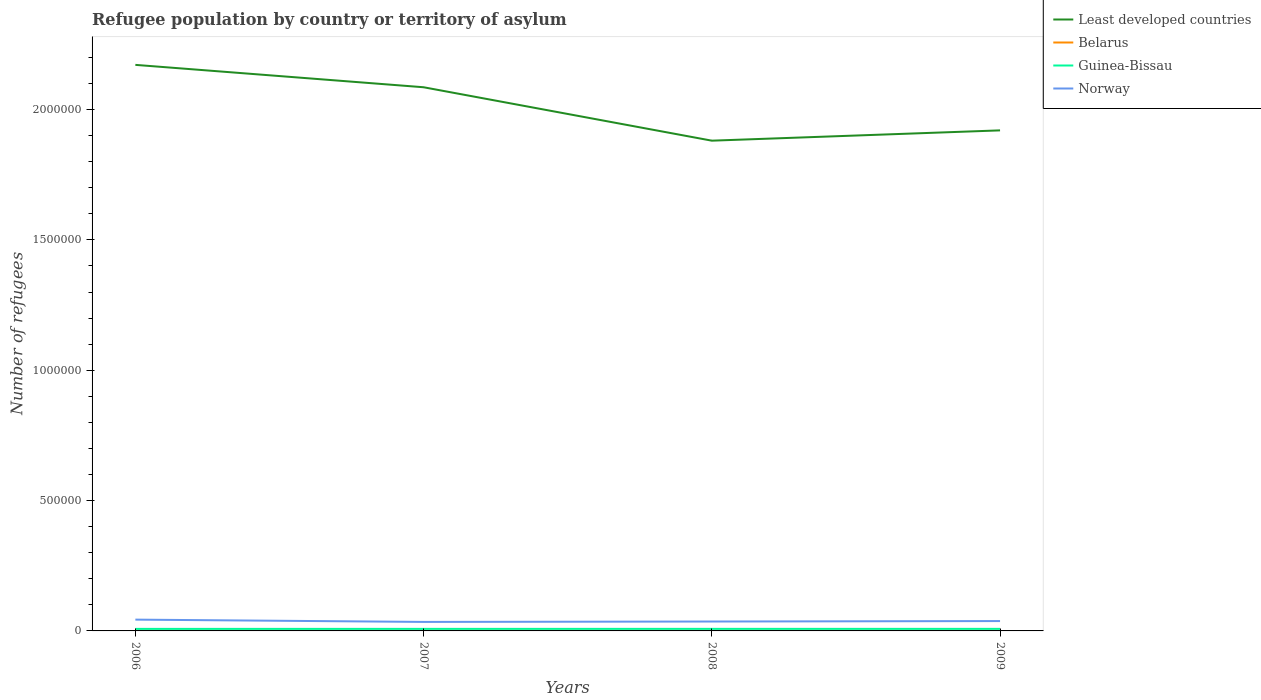How many different coloured lines are there?
Provide a succinct answer. 4. Is the number of lines equal to the number of legend labels?
Give a very brief answer. Yes. Across all years, what is the maximum number of refugees in Guinea-Bissau?
Your response must be concise. 7804. In which year was the number of refugees in Guinea-Bissau maximum?
Keep it short and to the point. 2006. What is the total number of refugees in Least developed countries in the graph?
Provide a succinct answer. 2.91e+05. What is the difference between the highest and the second highest number of refugees in Belarus?
Offer a terse response. 110. How many lines are there?
Your answer should be compact. 4. Are the values on the major ticks of Y-axis written in scientific E-notation?
Your answer should be compact. No. Does the graph contain grids?
Provide a succinct answer. No. How are the legend labels stacked?
Ensure brevity in your answer.  Vertical. What is the title of the graph?
Your response must be concise. Refugee population by country or territory of asylum. Does "Sri Lanka" appear as one of the legend labels in the graph?
Provide a succinct answer. No. What is the label or title of the Y-axis?
Keep it short and to the point. Number of refugees. What is the Number of refugees of Least developed countries in 2006?
Your response must be concise. 2.17e+06. What is the Number of refugees of Belarus in 2006?
Provide a succinct answer. 690. What is the Number of refugees of Guinea-Bissau in 2006?
Make the answer very short. 7804. What is the Number of refugees in Norway in 2006?
Your answer should be very brief. 4.33e+04. What is the Number of refugees in Least developed countries in 2007?
Offer a very short reply. 2.09e+06. What is the Number of refugees in Belarus in 2007?
Your response must be concise. 649. What is the Number of refugees in Guinea-Bissau in 2007?
Keep it short and to the point. 7860. What is the Number of refugees of Norway in 2007?
Ensure brevity in your answer.  3.45e+04. What is the Number of refugees of Least developed countries in 2008?
Offer a terse response. 1.88e+06. What is the Number of refugees of Belarus in 2008?
Make the answer very short. 609. What is the Number of refugees of Guinea-Bissau in 2008?
Provide a short and direct response. 7884. What is the Number of refugees of Norway in 2008?
Provide a succinct answer. 3.61e+04. What is the Number of refugees of Least developed countries in 2009?
Your answer should be very brief. 1.92e+06. What is the Number of refugees in Belarus in 2009?
Offer a very short reply. 580. What is the Number of refugees of Guinea-Bissau in 2009?
Provide a short and direct response. 7898. What is the Number of refugees in Norway in 2009?
Keep it short and to the point. 3.78e+04. Across all years, what is the maximum Number of refugees in Least developed countries?
Ensure brevity in your answer.  2.17e+06. Across all years, what is the maximum Number of refugees in Belarus?
Offer a terse response. 690. Across all years, what is the maximum Number of refugees in Guinea-Bissau?
Your answer should be very brief. 7898. Across all years, what is the maximum Number of refugees in Norway?
Give a very brief answer. 4.33e+04. Across all years, what is the minimum Number of refugees in Least developed countries?
Your answer should be compact. 1.88e+06. Across all years, what is the minimum Number of refugees of Belarus?
Ensure brevity in your answer.  580. Across all years, what is the minimum Number of refugees of Guinea-Bissau?
Your answer should be compact. 7804. Across all years, what is the minimum Number of refugees in Norway?
Provide a succinct answer. 3.45e+04. What is the total Number of refugees of Least developed countries in the graph?
Your response must be concise. 8.06e+06. What is the total Number of refugees of Belarus in the graph?
Give a very brief answer. 2528. What is the total Number of refugees of Guinea-Bissau in the graph?
Offer a terse response. 3.14e+04. What is the total Number of refugees in Norway in the graph?
Your answer should be compact. 1.52e+05. What is the difference between the Number of refugees in Least developed countries in 2006 and that in 2007?
Your answer should be compact. 8.58e+04. What is the difference between the Number of refugees of Belarus in 2006 and that in 2007?
Provide a succinct answer. 41. What is the difference between the Number of refugees of Guinea-Bissau in 2006 and that in 2007?
Offer a very short reply. -56. What is the difference between the Number of refugees in Norway in 2006 and that in 2007?
Your answer should be compact. 8814. What is the difference between the Number of refugees in Least developed countries in 2006 and that in 2008?
Ensure brevity in your answer.  2.91e+05. What is the difference between the Number of refugees in Belarus in 2006 and that in 2008?
Provide a succinct answer. 81. What is the difference between the Number of refugees of Guinea-Bissau in 2006 and that in 2008?
Make the answer very short. -80. What is the difference between the Number of refugees in Norway in 2006 and that in 2008?
Ensure brevity in your answer.  7235. What is the difference between the Number of refugees of Least developed countries in 2006 and that in 2009?
Give a very brief answer. 2.51e+05. What is the difference between the Number of refugees in Belarus in 2006 and that in 2009?
Your answer should be very brief. 110. What is the difference between the Number of refugees of Guinea-Bissau in 2006 and that in 2009?
Your response must be concise. -94. What is the difference between the Number of refugees of Norway in 2006 and that in 2009?
Offer a terse response. 5510. What is the difference between the Number of refugees of Least developed countries in 2007 and that in 2008?
Give a very brief answer. 2.05e+05. What is the difference between the Number of refugees in Guinea-Bissau in 2007 and that in 2008?
Provide a succinct answer. -24. What is the difference between the Number of refugees in Norway in 2007 and that in 2008?
Offer a very short reply. -1579. What is the difference between the Number of refugees of Least developed countries in 2007 and that in 2009?
Provide a short and direct response. 1.65e+05. What is the difference between the Number of refugees of Guinea-Bissau in 2007 and that in 2009?
Provide a succinct answer. -38. What is the difference between the Number of refugees in Norway in 2007 and that in 2009?
Make the answer very short. -3304. What is the difference between the Number of refugees in Least developed countries in 2008 and that in 2009?
Offer a terse response. -3.95e+04. What is the difference between the Number of refugees of Belarus in 2008 and that in 2009?
Ensure brevity in your answer.  29. What is the difference between the Number of refugees in Norway in 2008 and that in 2009?
Your response must be concise. -1725. What is the difference between the Number of refugees in Least developed countries in 2006 and the Number of refugees in Belarus in 2007?
Keep it short and to the point. 2.17e+06. What is the difference between the Number of refugees of Least developed countries in 2006 and the Number of refugees of Guinea-Bissau in 2007?
Your response must be concise. 2.16e+06. What is the difference between the Number of refugees of Least developed countries in 2006 and the Number of refugees of Norway in 2007?
Your answer should be very brief. 2.14e+06. What is the difference between the Number of refugees in Belarus in 2006 and the Number of refugees in Guinea-Bissau in 2007?
Give a very brief answer. -7170. What is the difference between the Number of refugees in Belarus in 2006 and the Number of refugees in Norway in 2007?
Your answer should be compact. -3.38e+04. What is the difference between the Number of refugees of Guinea-Bissau in 2006 and the Number of refugees of Norway in 2007?
Give a very brief answer. -2.67e+04. What is the difference between the Number of refugees in Least developed countries in 2006 and the Number of refugees in Belarus in 2008?
Your answer should be very brief. 2.17e+06. What is the difference between the Number of refugees of Least developed countries in 2006 and the Number of refugees of Guinea-Bissau in 2008?
Make the answer very short. 2.16e+06. What is the difference between the Number of refugees of Least developed countries in 2006 and the Number of refugees of Norway in 2008?
Make the answer very short. 2.14e+06. What is the difference between the Number of refugees in Belarus in 2006 and the Number of refugees in Guinea-Bissau in 2008?
Your answer should be compact. -7194. What is the difference between the Number of refugees in Belarus in 2006 and the Number of refugees in Norway in 2008?
Offer a very short reply. -3.54e+04. What is the difference between the Number of refugees in Guinea-Bissau in 2006 and the Number of refugees in Norway in 2008?
Your response must be concise. -2.83e+04. What is the difference between the Number of refugees in Least developed countries in 2006 and the Number of refugees in Belarus in 2009?
Your answer should be very brief. 2.17e+06. What is the difference between the Number of refugees of Least developed countries in 2006 and the Number of refugees of Guinea-Bissau in 2009?
Your answer should be very brief. 2.16e+06. What is the difference between the Number of refugees in Least developed countries in 2006 and the Number of refugees in Norway in 2009?
Provide a short and direct response. 2.13e+06. What is the difference between the Number of refugees of Belarus in 2006 and the Number of refugees of Guinea-Bissau in 2009?
Offer a very short reply. -7208. What is the difference between the Number of refugees of Belarus in 2006 and the Number of refugees of Norway in 2009?
Your response must be concise. -3.71e+04. What is the difference between the Number of refugees in Guinea-Bissau in 2006 and the Number of refugees in Norway in 2009?
Provide a succinct answer. -3.00e+04. What is the difference between the Number of refugees in Least developed countries in 2007 and the Number of refugees in Belarus in 2008?
Provide a short and direct response. 2.09e+06. What is the difference between the Number of refugees of Least developed countries in 2007 and the Number of refugees of Guinea-Bissau in 2008?
Your answer should be compact. 2.08e+06. What is the difference between the Number of refugees in Least developed countries in 2007 and the Number of refugees in Norway in 2008?
Give a very brief answer. 2.05e+06. What is the difference between the Number of refugees in Belarus in 2007 and the Number of refugees in Guinea-Bissau in 2008?
Keep it short and to the point. -7235. What is the difference between the Number of refugees of Belarus in 2007 and the Number of refugees of Norway in 2008?
Offer a terse response. -3.55e+04. What is the difference between the Number of refugees in Guinea-Bissau in 2007 and the Number of refugees in Norway in 2008?
Your answer should be compact. -2.82e+04. What is the difference between the Number of refugees in Least developed countries in 2007 and the Number of refugees in Belarus in 2009?
Your response must be concise. 2.09e+06. What is the difference between the Number of refugees in Least developed countries in 2007 and the Number of refugees in Guinea-Bissau in 2009?
Provide a short and direct response. 2.08e+06. What is the difference between the Number of refugees in Least developed countries in 2007 and the Number of refugees in Norway in 2009?
Provide a succinct answer. 2.05e+06. What is the difference between the Number of refugees of Belarus in 2007 and the Number of refugees of Guinea-Bissau in 2009?
Keep it short and to the point. -7249. What is the difference between the Number of refugees in Belarus in 2007 and the Number of refugees in Norway in 2009?
Your answer should be very brief. -3.72e+04. What is the difference between the Number of refugees of Guinea-Bissau in 2007 and the Number of refugees of Norway in 2009?
Offer a very short reply. -3.00e+04. What is the difference between the Number of refugees of Least developed countries in 2008 and the Number of refugees of Belarus in 2009?
Provide a succinct answer. 1.88e+06. What is the difference between the Number of refugees in Least developed countries in 2008 and the Number of refugees in Guinea-Bissau in 2009?
Give a very brief answer. 1.87e+06. What is the difference between the Number of refugees of Least developed countries in 2008 and the Number of refugees of Norway in 2009?
Keep it short and to the point. 1.84e+06. What is the difference between the Number of refugees of Belarus in 2008 and the Number of refugees of Guinea-Bissau in 2009?
Make the answer very short. -7289. What is the difference between the Number of refugees in Belarus in 2008 and the Number of refugees in Norway in 2009?
Offer a very short reply. -3.72e+04. What is the difference between the Number of refugees of Guinea-Bissau in 2008 and the Number of refugees of Norway in 2009?
Your answer should be very brief. -2.99e+04. What is the average Number of refugees in Least developed countries per year?
Make the answer very short. 2.01e+06. What is the average Number of refugees of Belarus per year?
Your answer should be compact. 632. What is the average Number of refugees in Guinea-Bissau per year?
Ensure brevity in your answer.  7861.5. What is the average Number of refugees of Norway per year?
Give a very brief answer. 3.79e+04. In the year 2006, what is the difference between the Number of refugees of Least developed countries and Number of refugees of Belarus?
Offer a terse response. 2.17e+06. In the year 2006, what is the difference between the Number of refugees in Least developed countries and Number of refugees in Guinea-Bissau?
Your answer should be very brief. 2.16e+06. In the year 2006, what is the difference between the Number of refugees of Least developed countries and Number of refugees of Norway?
Give a very brief answer. 2.13e+06. In the year 2006, what is the difference between the Number of refugees of Belarus and Number of refugees of Guinea-Bissau?
Your answer should be very brief. -7114. In the year 2006, what is the difference between the Number of refugees of Belarus and Number of refugees of Norway?
Your response must be concise. -4.26e+04. In the year 2006, what is the difference between the Number of refugees in Guinea-Bissau and Number of refugees in Norway?
Provide a short and direct response. -3.55e+04. In the year 2007, what is the difference between the Number of refugees of Least developed countries and Number of refugees of Belarus?
Ensure brevity in your answer.  2.09e+06. In the year 2007, what is the difference between the Number of refugees of Least developed countries and Number of refugees of Guinea-Bissau?
Offer a very short reply. 2.08e+06. In the year 2007, what is the difference between the Number of refugees in Least developed countries and Number of refugees in Norway?
Your answer should be compact. 2.05e+06. In the year 2007, what is the difference between the Number of refugees of Belarus and Number of refugees of Guinea-Bissau?
Your answer should be very brief. -7211. In the year 2007, what is the difference between the Number of refugees of Belarus and Number of refugees of Norway?
Provide a succinct answer. -3.39e+04. In the year 2007, what is the difference between the Number of refugees of Guinea-Bissau and Number of refugees of Norway?
Provide a succinct answer. -2.67e+04. In the year 2008, what is the difference between the Number of refugees of Least developed countries and Number of refugees of Belarus?
Offer a terse response. 1.88e+06. In the year 2008, what is the difference between the Number of refugees of Least developed countries and Number of refugees of Guinea-Bissau?
Your answer should be very brief. 1.87e+06. In the year 2008, what is the difference between the Number of refugees in Least developed countries and Number of refugees in Norway?
Offer a terse response. 1.84e+06. In the year 2008, what is the difference between the Number of refugees in Belarus and Number of refugees in Guinea-Bissau?
Ensure brevity in your answer.  -7275. In the year 2008, what is the difference between the Number of refugees of Belarus and Number of refugees of Norway?
Your response must be concise. -3.55e+04. In the year 2008, what is the difference between the Number of refugees of Guinea-Bissau and Number of refugees of Norway?
Offer a very short reply. -2.82e+04. In the year 2009, what is the difference between the Number of refugees of Least developed countries and Number of refugees of Belarus?
Make the answer very short. 1.92e+06. In the year 2009, what is the difference between the Number of refugees of Least developed countries and Number of refugees of Guinea-Bissau?
Offer a terse response. 1.91e+06. In the year 2009, what is the difference between the Number of refugees in Least developed countries and Number of refugees in Norway?
Offer a very short reply. 1.88e+06. In the year 2009, what is the difference between the Number of refugees in Belarus and Number of refugees in Guinea-Bissau?
Keep it short and to the point. -7318. In the year 2009, what is the difference between the Number of refugees of Belarus and Number of refugees of Norway?
Your answer should be compact. -3.72e+04. In the year 2009, what is the difference between the Number of refugees of Guinea-Bissau and Number of refugees of Norway?
Provide a succinct answer. -2.99e+04. What is the ratio of the Number of refugees of Least developed countries in 2006 to that in 2007?
Your response must be concise. 1.04. What is the ratio of the Number of refugees in Belarus in 2006 to that in 2007?
Ensure brevity in your answer.  1.06. What is the ratio of the Number of refugees of Norway in 2006 to that in 2007?
Your response must be concise. 1.26. What is the ratio of the Number of refugees of Least developed countries in 2006 to that in 2008?
Ensure brevity in your answer.  1.15. What is the ratio of the Number of refugees of Belarus in 2006 to that in 2008?
Your answer should be very brief. 1.13. What is the ratio of the Number of refugees in Guinea-Bissau in 2006 to that in 2008?
Offer a very short reply. 0.99. What is the ratio of the Number of refugees of Norway in 2006 to that in 2008?
Offer a terse response. 1.2. What is the ratio of the Number of refugees in Least developed countries in 2006 to that in 2009?
Make the answer very short. 1.13. What is the ratio of the Number of refugees of Belarus in 2006 to that in 2009?
Provide a short and direct response. 1.19. What is the ratio of the Number of refugees of Guinea-Bissau in 2006 to that in 2009?
Keep it short and to the point. 0.99. What is the ratio of the Number of refugees of Norway in 2006 to that in 2009?
Make the answer very short. 1.15. What is the ratio of the Number of refugees in Least developed countries in 2007 to that in 2008?
Your answer should be compact. 1.11. What is the ratio of the Number of refugees of Belarus in 2007 to that in 2008?
Keep it short and to the point. 1.07. What is the ratio of the Number of refugees of Guinea-Bissau in 2007 to that in 2008?
Keep it short and to the point. 1. What is the ratio of the Number of refugees of Norway in 2007 to that in 2008?
Offer a very short reply. 0.96. What is the ratio of the Number of refugees of Least developed countries in 2007 to that in 2009?
Your answer should be very brief. 1.09. What is the ratio of the Number of refugees in Belarus in 2007 to that in 2009?
Your answer should be compact. 1.12. What is the ratio of the Number of refugees in Guinea-Bissau in 2007 to that in 2009?
Your answer should be very brief. 1. What is the ratio of the Number of refugees in Norway in 2007 to that in 2009?
Your response must be concise. 0.91. What is the ratio of the Number of refugees in Least developed countries in 2008 to that in 2009?
Your answer should be very brief. 0.98. What is the ratio of the Number of refugees of Guinea-Bissau in 2008 to that in 2009?
Your answer should be compact. 1. What is the ratio of the Number of refugees in Norway in 2008 to that in 2009?
Your answer should be very brief. 0.95. What is the difference between the highest and the second highest Number of refugees in Least developed countries?
Offer a terse response. 8.58e+04. What is the difference between the highest and the second highest Number of refugees in Norway?
Offer a terse response. 5510. What is the difference between the highest and the lowest Number of refugees of Least developed countries?
Provide a succinct answer. 2.91e+05. What is the difference between the highest and the lowest Number of refugees of Belarus?
Make the answer very short. 110. What is the difference between the highest and the lowest Number of refugees of Guinea-Bissau?
Provide a succinct answer. 94. What is the difference between the highest and the lowest Number of refugees in Norway?
Your response must be concise. 8814. 